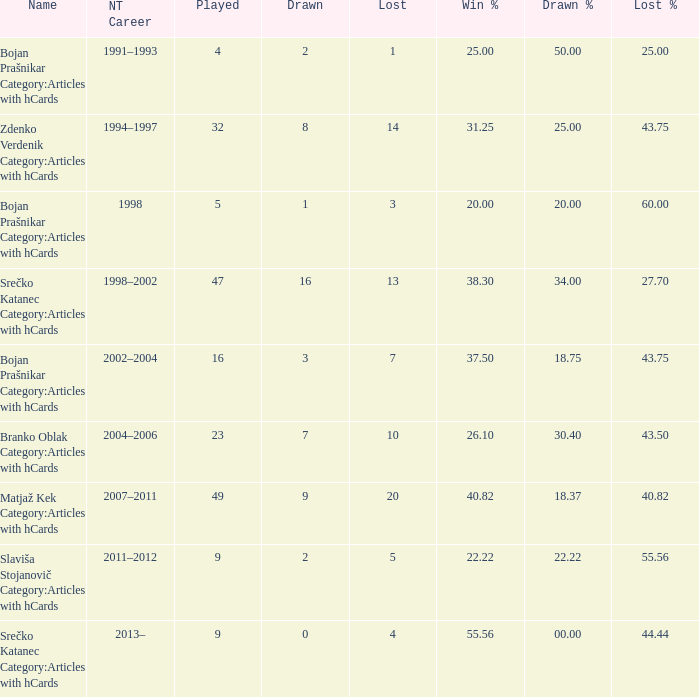What are the possible values for lost% when the number of drawn games is 8 and the number of lost games is less than 14? 0.0. 